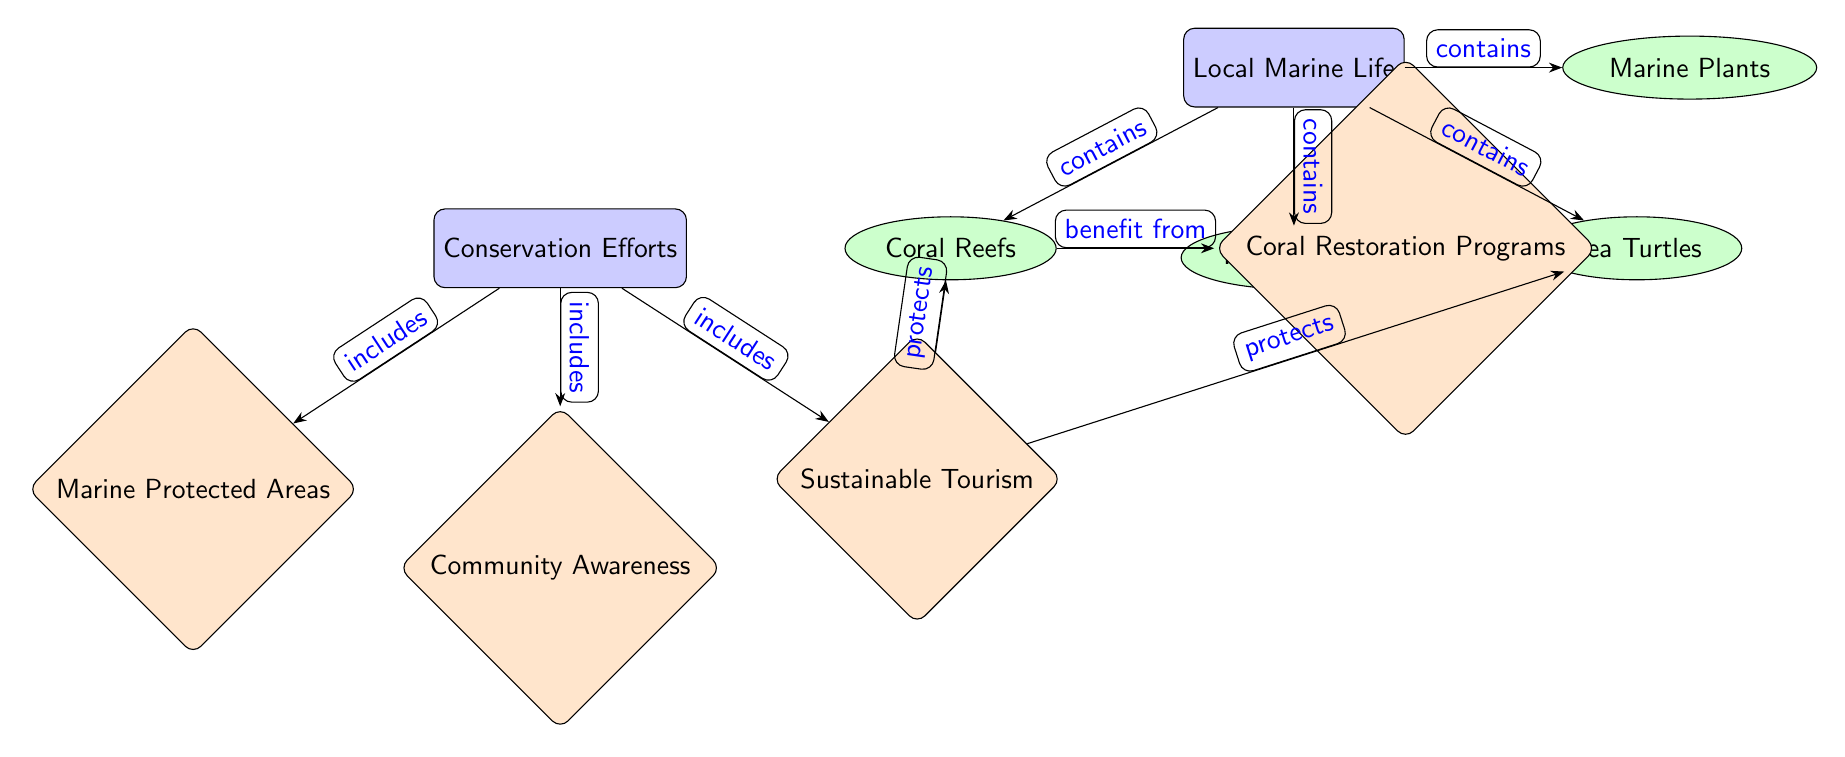What are the components of local marine life? The diagram lists four components of local marine life, which are Coral Reefs, Fish Species, Sea Turtles, and Marine Plants.
Answer: Coral Reefs, Fish Species, Sea Turtles, Marine Plants How many conservation efforts are shown in the diagram? There are four conservation efforts illustrated: Marine Protected Areas, Community Awareness, Sustainable Tourism, and Coral Restoration Programs.
Answer: Four Which conservation effort benefits the coral reefs? The Coral Restoration Programs are specifically stated to benefit from the existence of Coral Reefs.
Answer: Coral Restoration Programs What does sustainable tourism protect? According to the diagram, Sustainable Tourism protects both Coral Reefs and Sea Turtles.
Answer: Coral Reefs, Sea Turtles What type of relationship does "Marine Protected Areas" have with "Conservation Efforts"? The relationship is described as an "includes" connection, meaning Marine Protected Areas are part of the broader category of Conservation Efforts.
Answer: Includes Which component of local marine life is specifically linked to sustainable tourism? The diagram shows that Sustainable Tourism protects Coral Reefs and Sea Turtles, linking these components directly.
Answer: Coral Reefs, Sea Turtles How many nodes are categorized under local marine life? The nodes categorized under local marine life are four in total: Coral Reefs, Fish Species, Sea Turtles, and Marine Plants.
Answer: Four Which conservation effort raises community awareness? Community Awareness is the only conservation effort within the diagram that focuses on raising awareness among the community.
Answer: Community Awareness How do coral reefs benefit from conservation efforts? Coral Reefs benefit from Coral Restoration Programs, which are one of the conservation efforts aimed at restoring coral health and biodiversity.
Answer: Coral Restoration Programs 